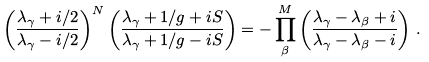<formula> <loc_0><loc_0><loc_500><loc_500>\left ( \frac { \lambda _ { \gamma } + i / 2 } { \lambda _ { \gamma } - i / 2 } \right ) ^ { N } \left ( \frac { \lambda _ { \gamma } + 1 / g + i S } { \lambda _ { \gamma } + 1 / g - i S } \right ) = - \prod _ { \beta } ^ { M } \left ( \frac { \lambda _ { \gamma } - \lambda _ { \beta } + i } { \lambda _ { \gamma } - \lambda _ { \beta } - i } \right ) \, .</formula> 